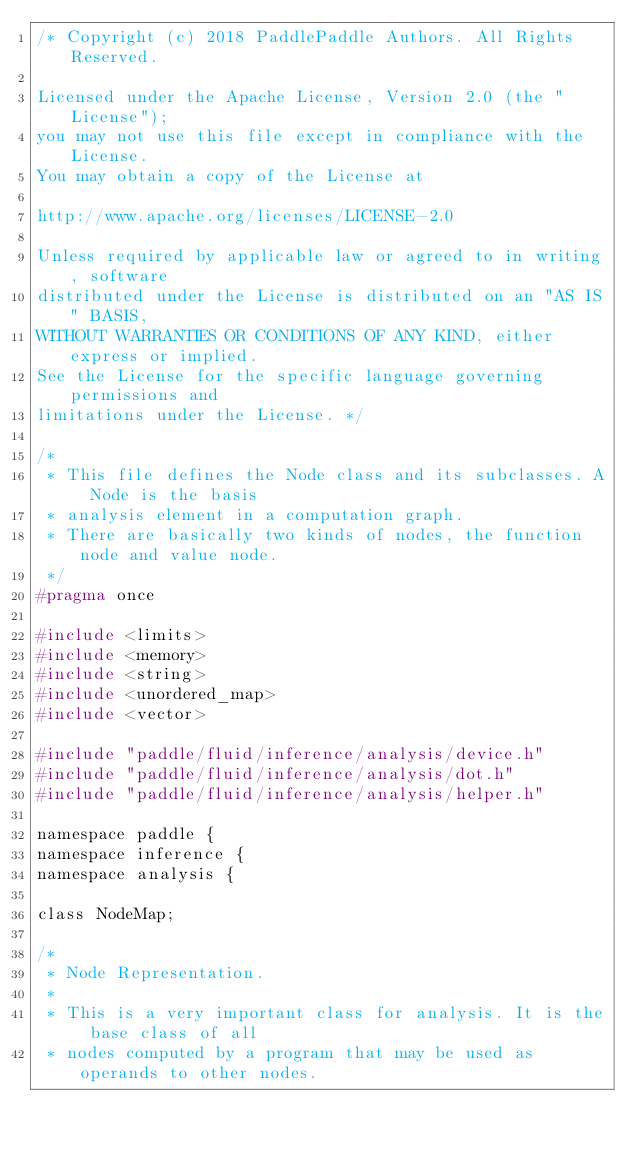Convert code to text. <code><loc_0><loc_0><loc_500><loc_500><_C_>/* Copyright (c) 2018 PaddlePaddle Authors. All Rights Reserved.

Licensed under the Apache License, Version 2.0 (the "License");
you may not use this file except in compliance with the License.
You may obtain a copy of the License at

http://www.apache.org/licenses/LICENSE-2.0

Unless required by applicable law or agreed to in writing, software
distributed under the License is distributed on an "AS IS" BASIS,
WITHOUT WARRANTIES OR CONDITIONS OF ANY KIND, either express or implied.
See the License for the specific language governing permissions and
limitations under the License. */

/*
 * This file defines the Node class and its subclasses. A Node is the basis
 * analysis element in a computation graph.
 * There are basically two kinds of nodes, the function node and value node.
 */
#pragma once

#include <limits>
#include <memory>
#include <string>
#include <unordered_map>
#include <vector>

#include "paddle/fluid/inference/analysis/device.h"
#include "paddle/fluid/inference/analysis/dot.h"
#include "paddle/fluid/inference/analysis/helper.h"

namespace paddle {
namespace inference {
namespace analysis {

class NodeMap;

/*
 * Node Representation.
 *
 * This is a very important class for analysis. It is the base class of all
 * nodes computed by a program that may be used as operands to other nodes.</code> 